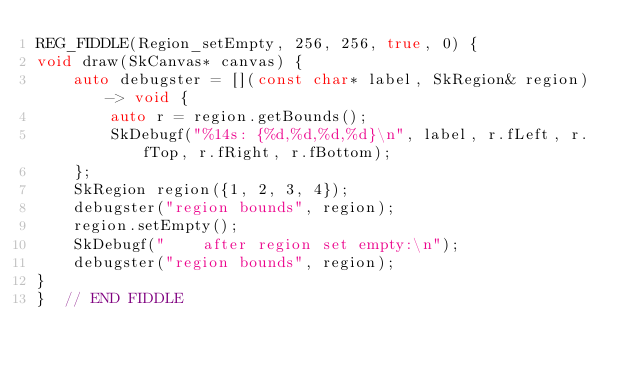Convert code to text. <code><loc_0><loc_0><loc_500><loc_500><_C++_>REG_FIDDLE(Region_setEmpty, 256, 256, true, 0) {
void draw(SkCanvas* canvas) {
    auto debugster = [](const char* label, SkRegion& region) -> void {
        auto r = region.getBounds();
        SkDebugf("%14s: {%d,%d,%d,%d}\n", label, r.fLeft, r.fTop, r.fRight, r.fBottom);
    };
    SkRegion region({1, 2, 3, 4});
    debugster("region bounds", region);
    region.setEmpty();
    SkDebugf("    after region set empty:\n");
    debugster("region bounds", region);
}
}  // END FIDDLE
</code> 